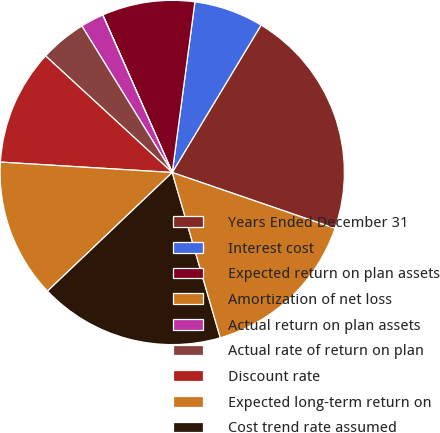<chart> <loc_0><loc_0><loc_500><loc_500><pie_chart><fcel>Years Ended December 31<fcel>Interest cost<fcel>Expected return on plan assets<fcel>Amortization of net loss<fcel>Actual return on plan assets<fcel>Actual rate of return on plan<fcel>Discount rate<fcel>Expected long-term return on<fcel>Cost trend rate assumed<fcel>Rate to which the cost trend<nl><fcel>21.63%<fcel>6.53%<fcel>8.71%<fcel>0.01%<fcel>2.18%<fcel>4.36%<fcel>10.88%<fcel>13.06%<fcel>17.4%<fcel>15.23%<nl></chart> 